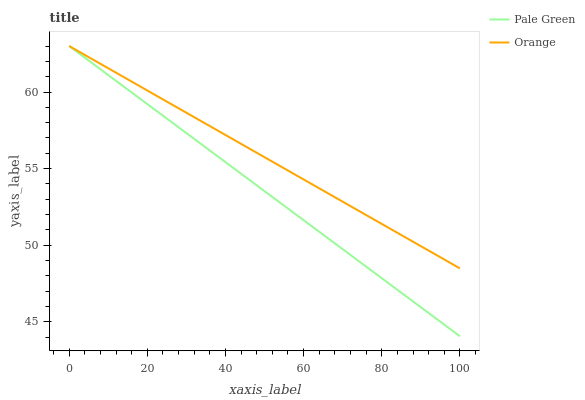Does Pale Green have the minimum area under the curve?
Answer yes or no. Yes. Does Orange have the maximum area under the curve?
Answer yes or no. Yes. Does Pale Green have the maximum area under the curve?
Answer yes or no. No. Is Orange the smoothest?
Answer yes or no. Yes. Is Pale Green the roughest?
Answer yes or no. Yes. Is Pale Green the smoothest?
Answer yes or no. No. Does Pale Green have the lowest value?
Answer yes or no. Yes. Does Pale Green have the highest value?
Answer yes or no. Yes. Does Pale Green intersect Orange?
Answer yes or no. Yes. Is Pale Green less than Orange?
Answer yes or no. No. Is Pale Green greater than Orange?
Answer yes or no. No. 